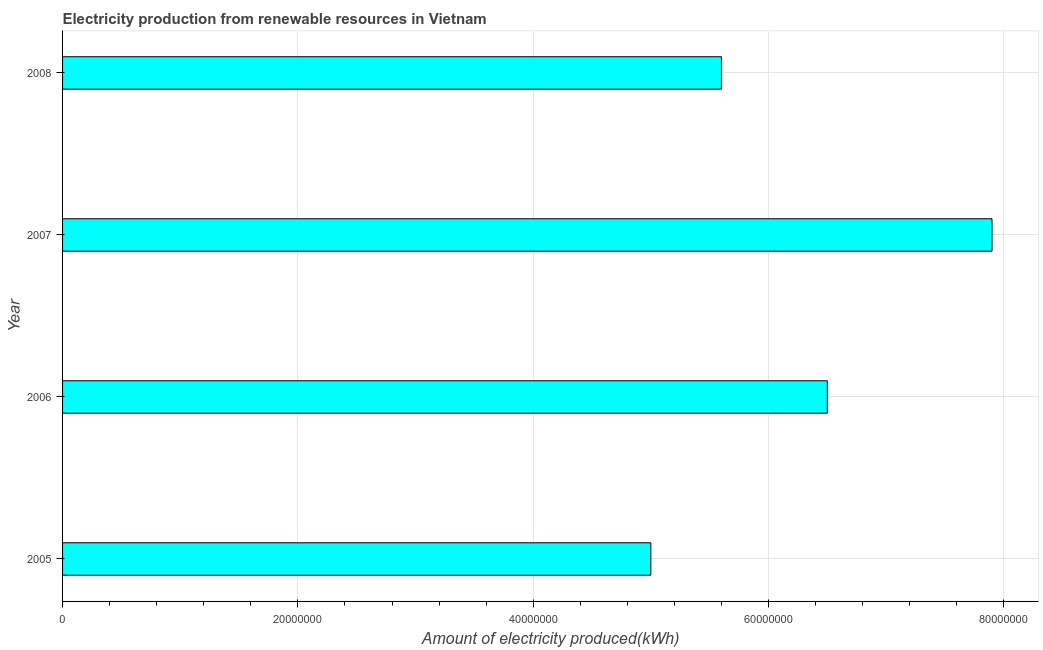Does the graph contain any zero values?
Your answer should be compact. No. What is the title of the graph?
Provide a succinct answer. Electricity production from renewable resources in Vietnam. What is the label or title of the X-axis?
Ensure brevity in your answer.  Amount of electricity produced(kWh). What is the amount of electricity produced in 2008?
Ensure brevity in your answer.  5.60e+07. Across all years, what is the maximum amount of electricity produced?
Give a very brief answer. 7.90e+07. Across all years, what is the minimum amount of electricity produced?
Give a very brief answer. 5.00e+07. In which year was the amount of electricity produced minimum?
Keep it short and to the point. 2005. What is the sum of the amount of electricity produced?
Your response must be concise. 2.50e+08. What is the difference between the amount of electricity produced in 2007 and 2008?
Make the answer very short. 2.30e+07. What is the average amount of electricity produced per year?
Keep it short and to the point. 6.25e+07. What is the median amount of electricity produced?
Offer a very short reply. 6.05e+07. In how many years, is the amount of electricity produced greater than 44000000 kWh?
Provide a succinct answer. 4. Do a majority of the years between 2006 and 2005 (inclusive) have amount of electricity produced greater than 36000000 kWh?
Provide a short and direct response. No. What is the ratio of the amount of electricity produced in 2006 to that in 2008?
Provide a short and direct response. 1.16. What is the difference between the highest and the second highest amount of electricity produced?
Your response must be concise. 1.40e+07. What is the difference between the highest and the lowest amount of electricity produced?
Offer a very short reply. 2.90e+07. In how many years, is the amount of electricity produced greater than the average amount of electricity produced taken over all years?
Keep it short and to the point. 2. Are all the bars in the graph horizontal?
Your answer should be very brief. Yes. How many years are there in the graph?
Your answer should be very brief. 4. What is the Amount of electricity produced(kWh) of 2006?
Your response must be concise. 6.50e+07. What is the Amount of electricity produced(kWh) of 2007?
Offer a terse response. 7.90e+07. What is the Amount of electricity produced(kWh) of 2008?
Give a very brief answer. 5.60e+07. What is the difference between the Amount of electricity produced(kWh) in 2005 and 2006?
Make the answer very short. -1.50e+07. What is the difference between the Amount of electricity produced(kWh) in 2005 and 2007?
Keep it short and to the point. -2.90e+07. What is the difference between the Amount of electricity produced(kWh) in 2005 and 2008?
Ensure brevity in your answer.  -6.00e+06. What is the difference between the Amount of electricity produced(kWh) in 2006 and 2007?
Your answer should be very brief. -1.40e+07. What is the difference between the Amount of electricity produced(kWh) in 2006 and 2008?
Offer a terse response. 9.00e+06. What is the difference between the Amount of electricity produced(kWh) in 2007 and 2008?
Give a very brief answer. 2.30e+07. What is the ratio of the Amount of electricity produced(kWh) in 2005 to that in 2006?
Keep it short and to the point. 0.77. What is the ratio of the Amount of electricity produced(kWh) in 2005 to that in 2007?
Your answer should be compact. 0.63. What is the ratio of the Amount of electricity produced(kWh) in 2005 to that in 2008?
Your answer should be very brief. 0.89. What is the ratio of the Amount of electricity produced(kWh) in 2006 to that in 2007?
Give a very brief answer. 0.82. What is the ratio of the Amount of electricity produced(kWh) in 2006 to that in 2008?
Offer a terse response. 1.16. What is the ratio of the Amount of electricity produced(kWh) in 2007 to that in 2008?
Make the answer very short. 1.41. 